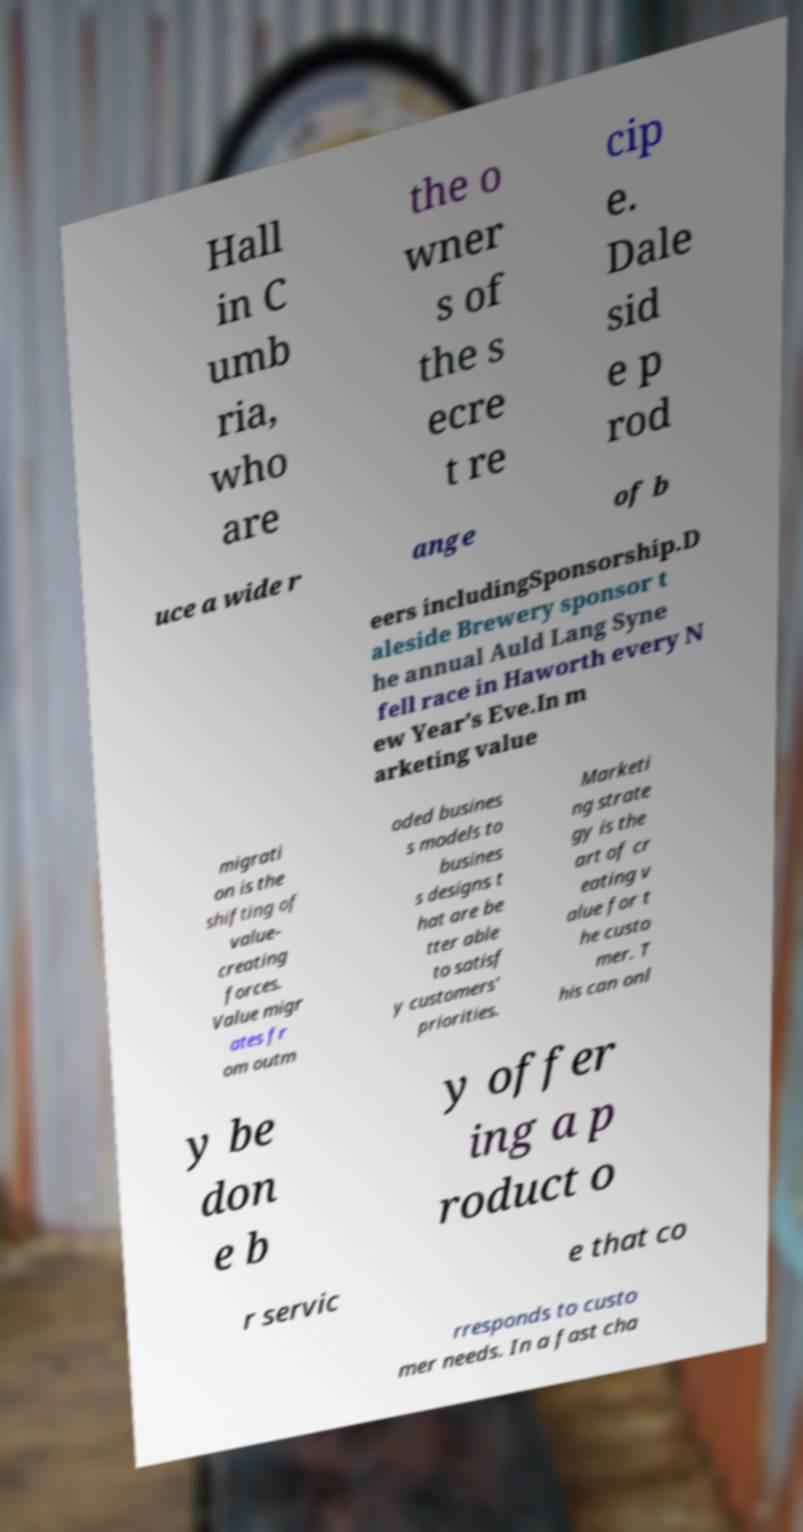For documentation purposes, I need the text within this image transcribed. Could you provide that? Hall in C umb ria, who are the o wner s of the s ecre t re cip e. Dale sid e p rod uce a wide r ange of b eers includingSponsorship.D aleside Brewery sponsor t he annual Auld Lang Syne fell race in Haworth every N ew Year's Eve.In m arketing value migrati on is the shifting of value- creating forces. Value migr ates fr om outm oded busines s models to busines s designs t hat are be tter able to satisf y customers' priorities. Marketi ng strate gy is the art of cr eating v alue for t he custo mer. T his can onl y be don e b y offer ing a p roduct o r servic e that co rresponds to custo mer needs. In a fast cha 